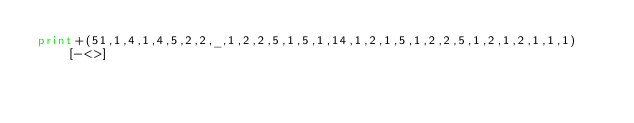Convert code to text. <code><loc_0><loc_0><loc_500><loc_500><_Perl_>print+(51,1,4,1,4,5,2,2,_,1,2,2,5,1,5,1,14,1,2,1,5,1,2,2,5,1,2,1,2,1,1,1)[-<>]</code> 